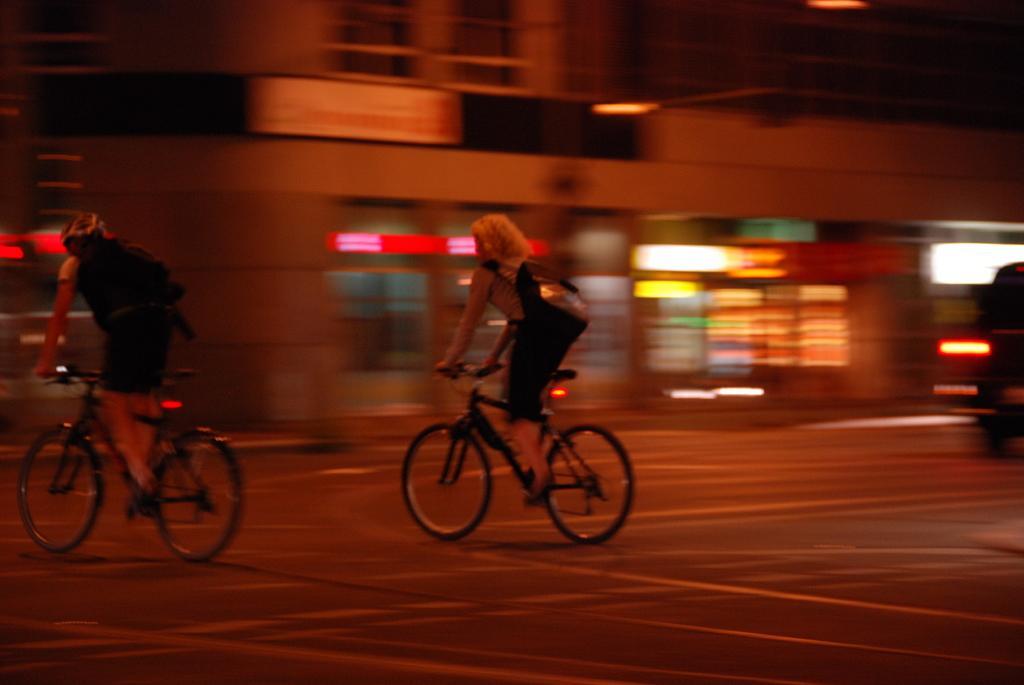Can you describe this image briefly? This picture shows couple of them riding bicycles and we see a building and a vehicle moving. 